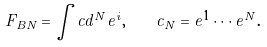<formula> <loc_0><loc_0><loc_500><loc_500>F _ { B N } = \int c d ^ { N } e ^ { i } , \quad c _ { N } = e ^ { 1 } \cdots e ^ { N } .</formula> 